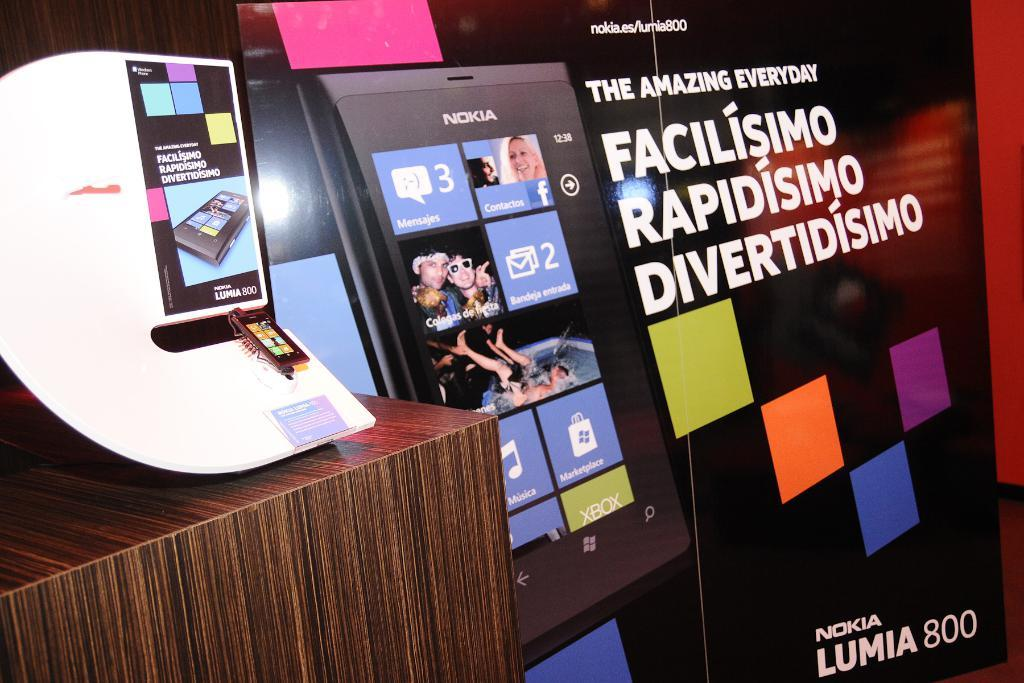<image>
Describe the image concisely. A Nokia Lumia 800 poster is on display 